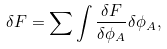Convert formula to latex. <formula><loc_0><loc_0><loc_500><loc_500>\delta F = \sum \int \frac { \delta F } { \delta \phi _ { A } } \delta \phi _ { A } ,</formula> 